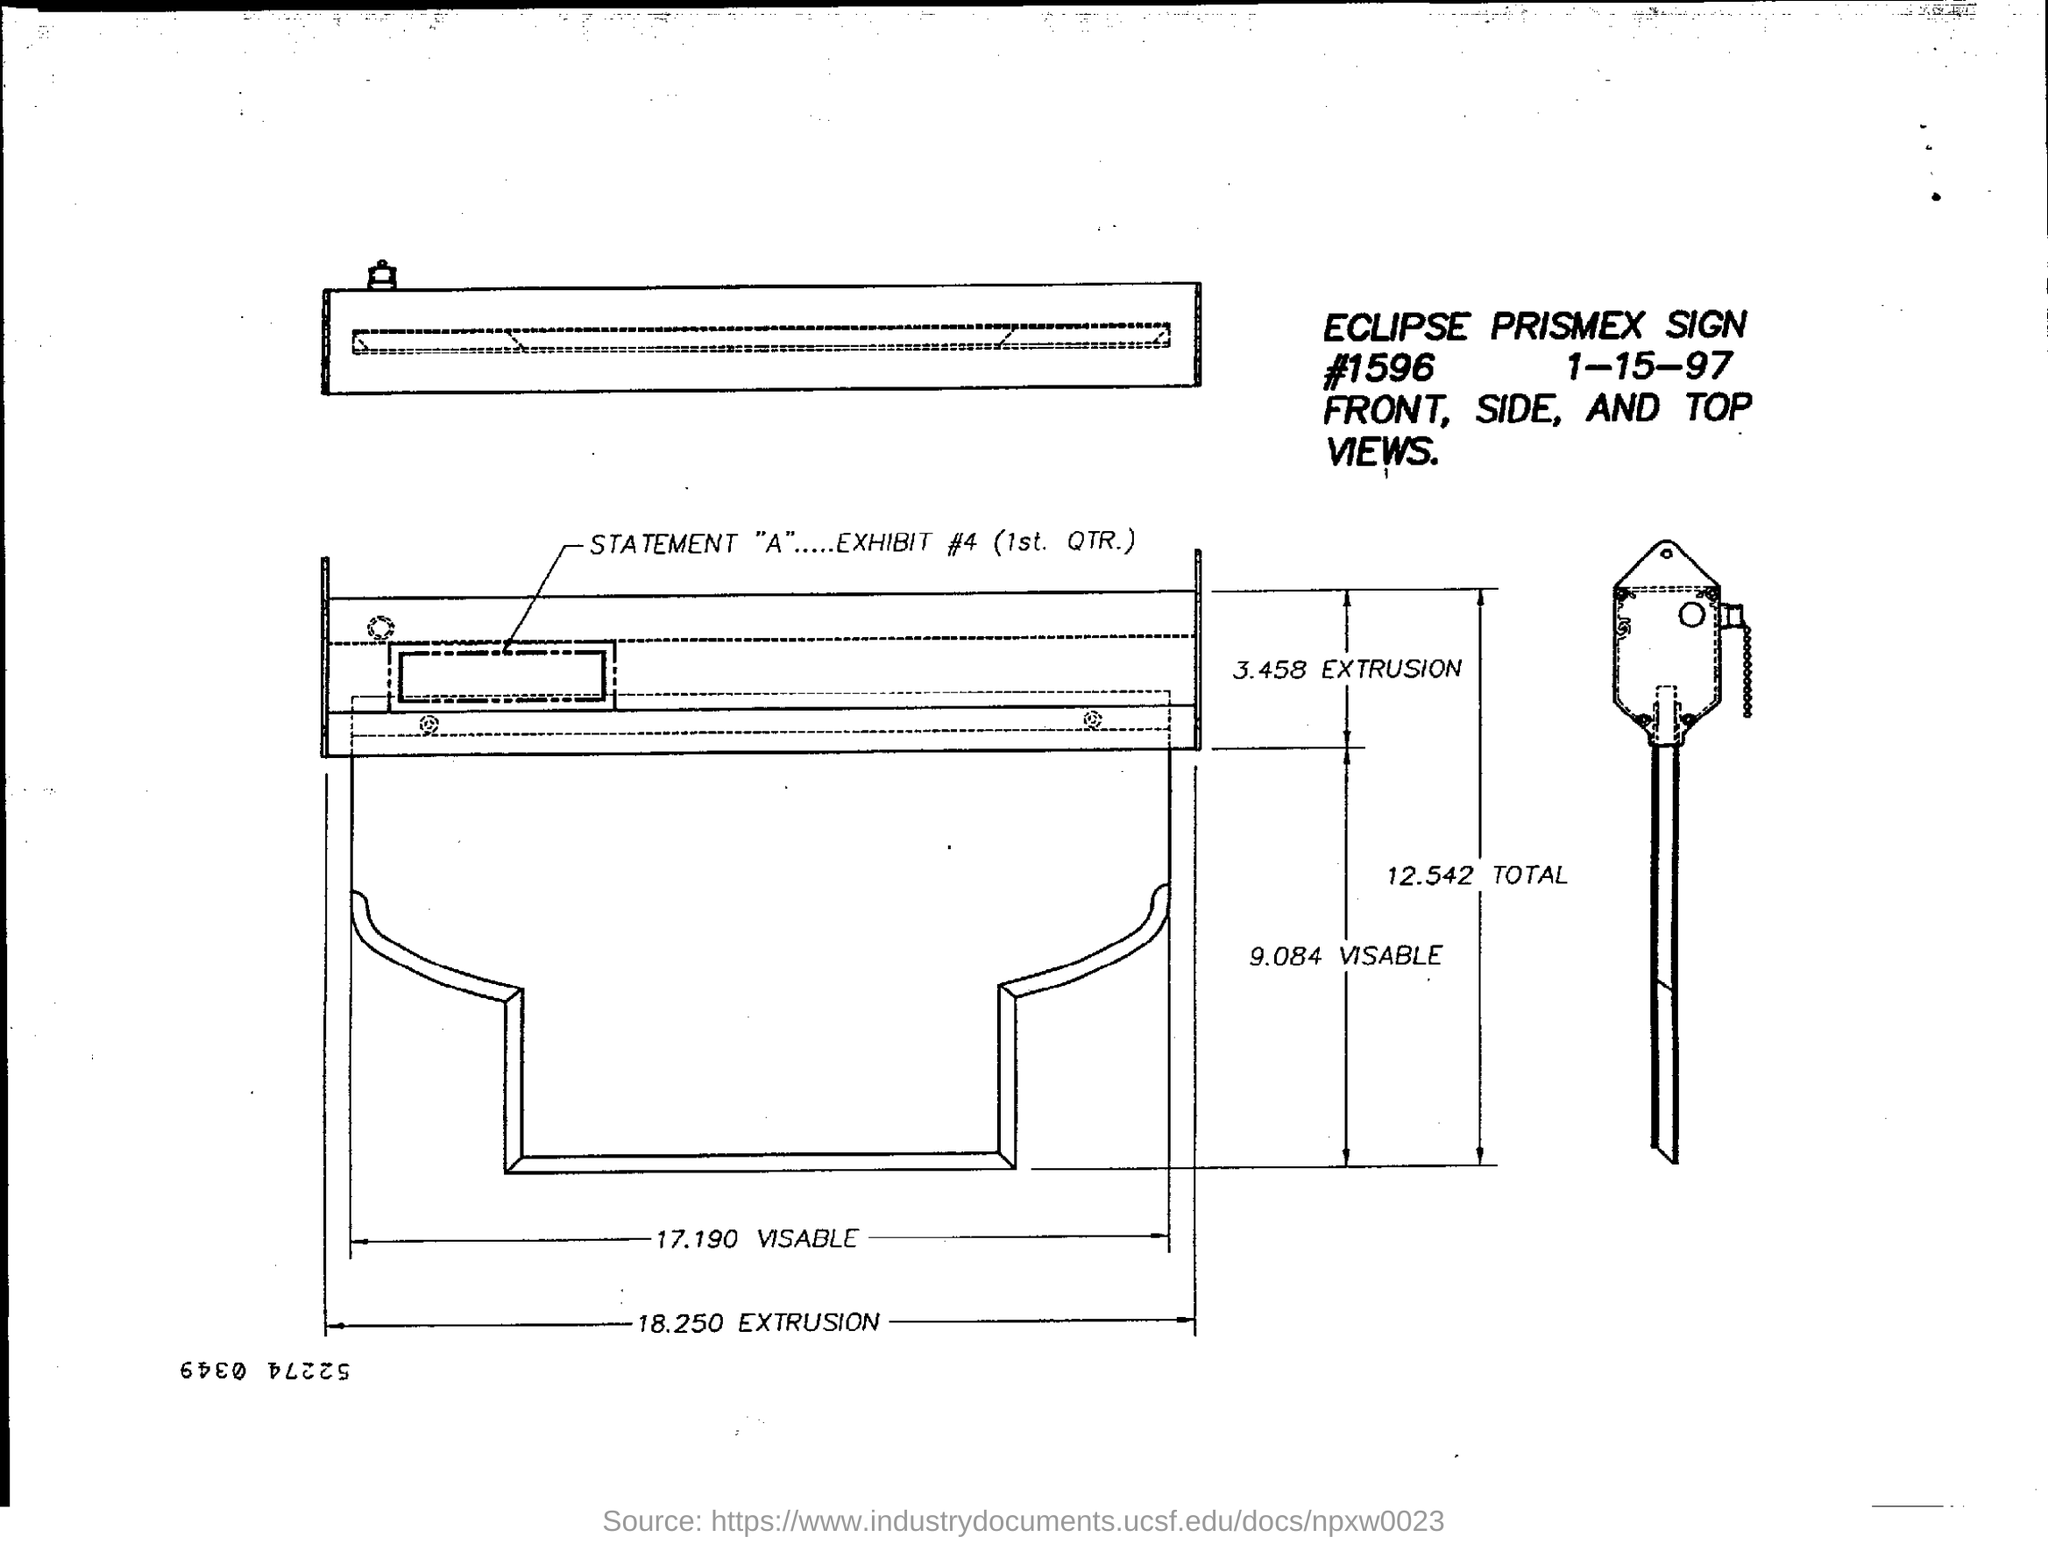Identify some key points in this picture. The exhibit number is #4 for the first quarter. 